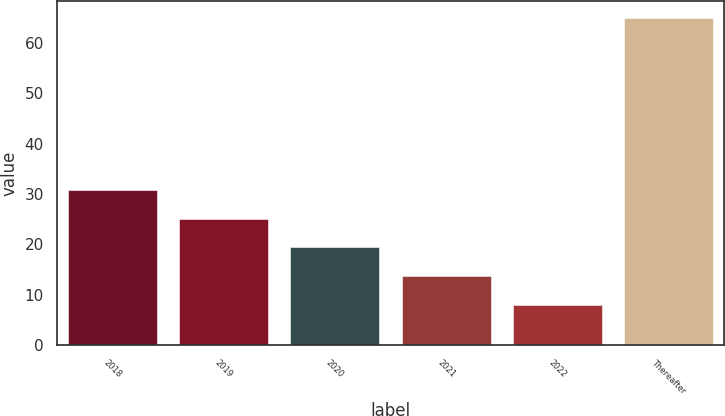<chart> <loc_0><loc_0><loc_500><loc_500><bar_chart><fcel>2018<fcel>2019<fcel>2020<fcel>2021<fcel>2022<fcel>Thereafter<nl><fcel>30.8<fcel>25.1<fcel>19.4<fcel>13.7<fcel>8<fcel>65<nl></chart> 